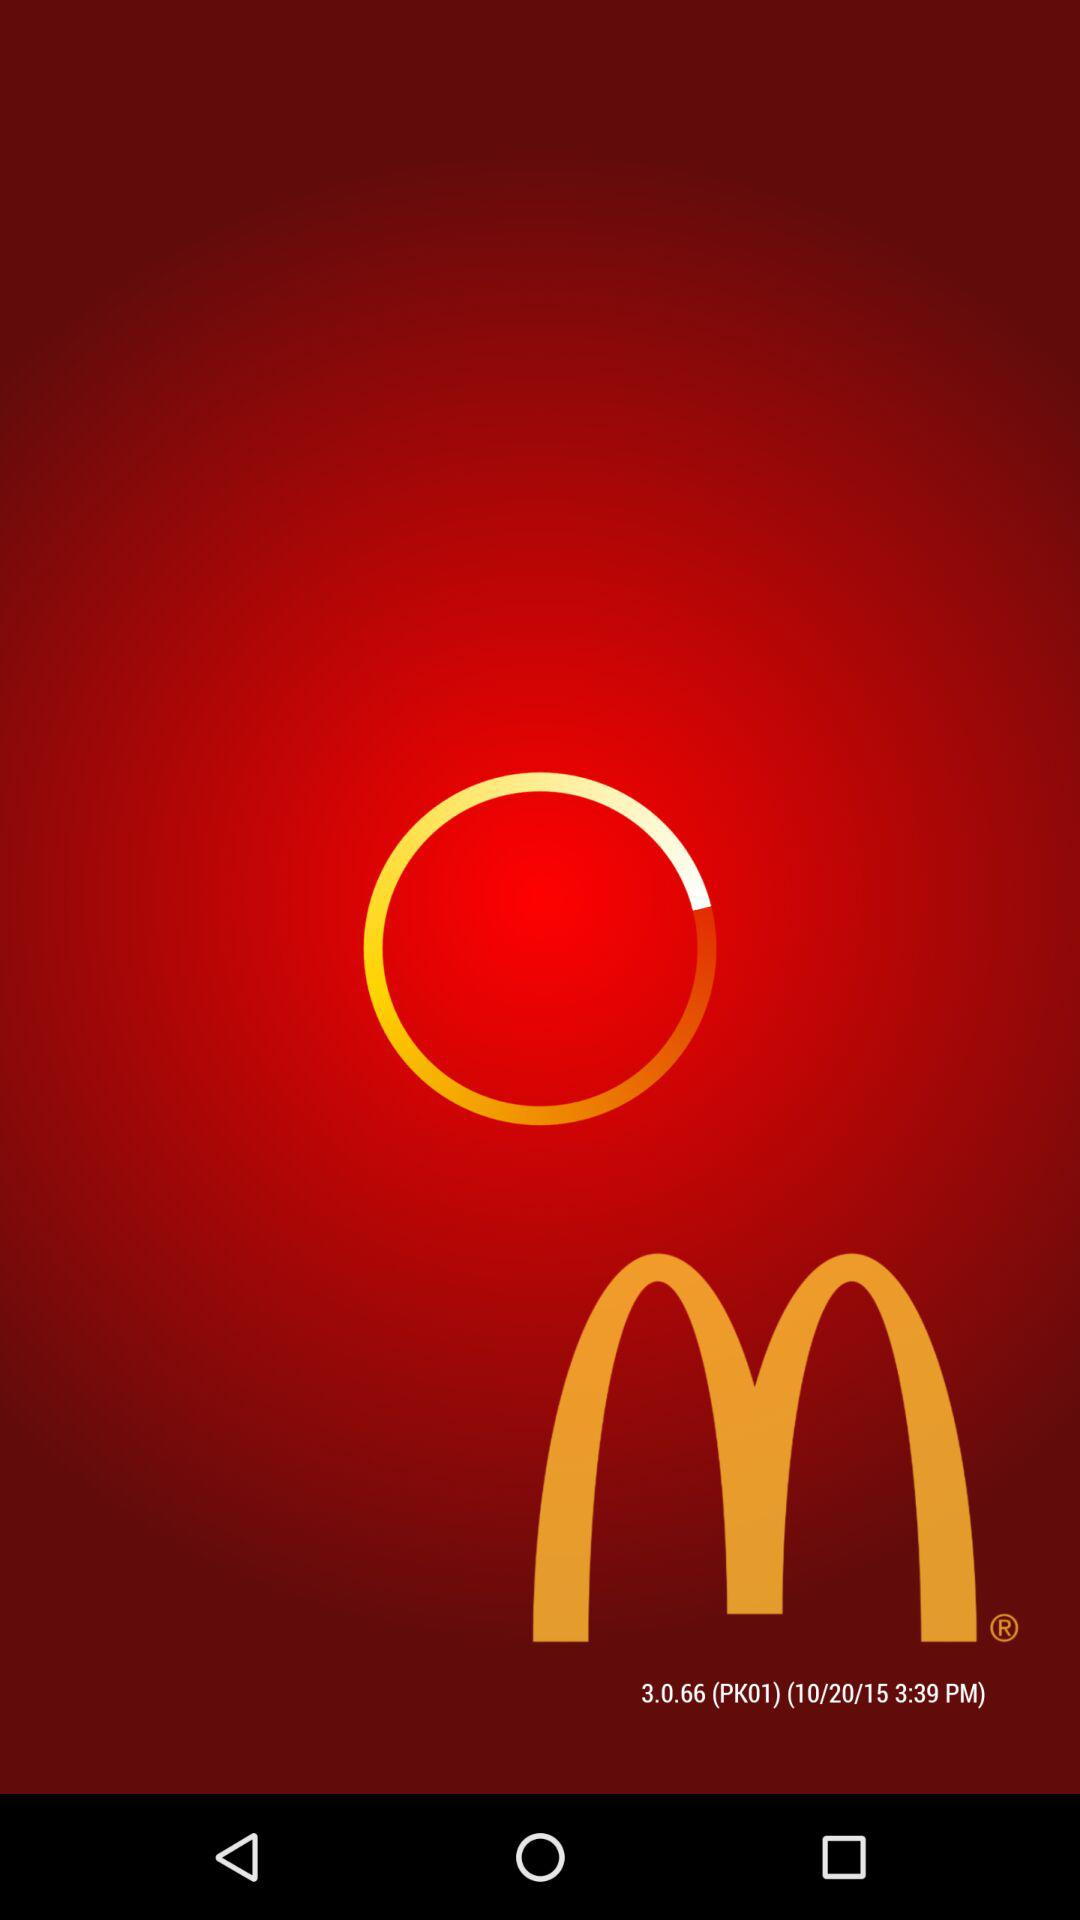What is the version? The version is 3.0.66. 